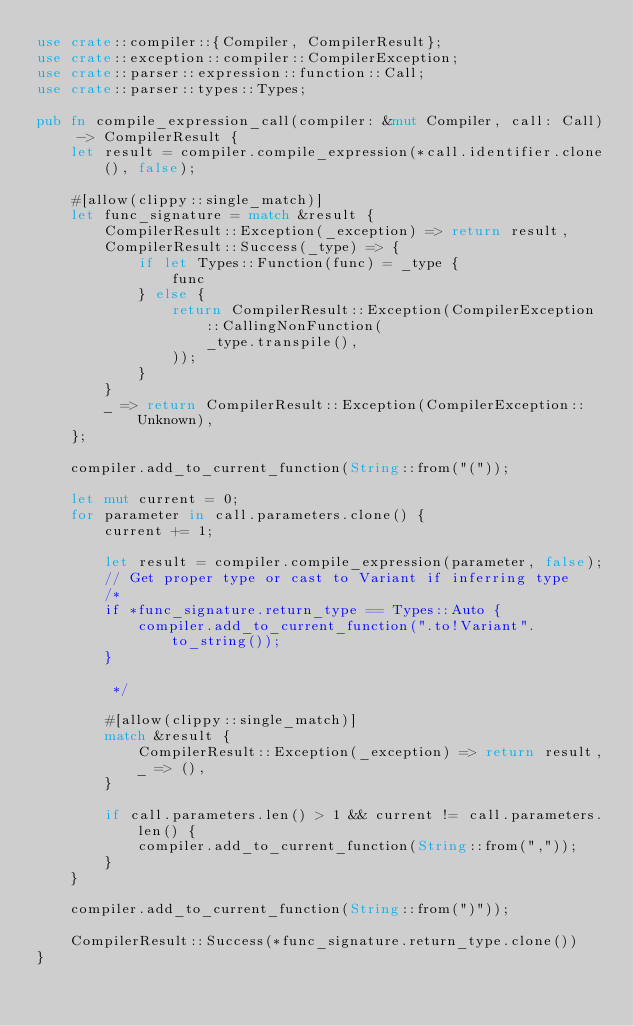Convert code to text. <code><loc_0><loc_0><loc_500><loc_500><_Rust_>use crate::compiler::{Compiler, CompilerResult};
use crate::exception::compiler::CompilerException;
use crate::parser::expression::function::Call;
use crate::parser::types::Types;

pub fn compile_expression_call(compiler: &mut Compiler, call: Call) -> CompilerResult {
    let result = compiler.compile_expression(*call.identifier.clone(), false);

    #[allow(clippy::single_match)]
    let func_signature = match &result {
        CompilerResult::Exception(_exception) => return result,
        CompilerResult::Success(_type) => {
            if let Types::Function(func) = _type {
                func
            } else {
                return CompilerResult::Exception(CompilerException::CallingNonFunction(
                    _type.transpile(),
                ));
            }
        }
        _ => return CompilerResult::Exception(CompilerException::Unknown),
    };

    compiler.add_to_current_function(String::from("("));

    let mut current = 0;
    for parameter in call.parameters.clone() {
        current += 1;

        let result = compiler.compile_expression(parameter, false);
        // Get proper type or cast to Variant if inferring type
        /*
        if *func_signature.return_type == Types::Auto {
            compiler.add_to_current_function(".to!Variant".to_string());
        }

         */

        #[allow(clippy::single_match)]
        match &result {
            CompilerResult::Exception(_exception) => return result,
            _ => (),
        }

        if call.parameters.len() > 1 && current != call.parameters.len() {
            compiler.add_to_current_function(String::from(","));
        }
    }

    compiler.add_to_current_function(String::from(")"));

    CompilerResult::Success(*func_signature.return_type.clone())
}
</code> 